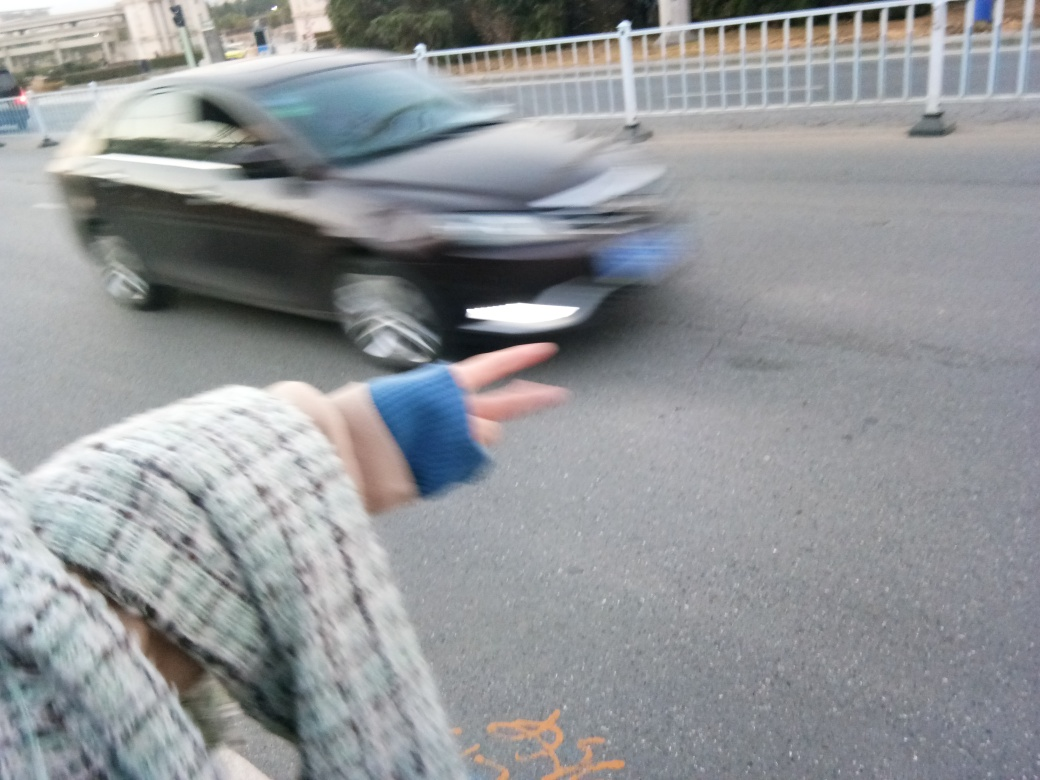Are there any clear and sharp subjects? While the foreground features an outstretched hand that is somewhat in focus, the rest of the image, especially the moving car, is blurred. This suggests a slower shutter speed or motion blur effect from the camera. The hand could be considered a clear subject, but because it occupies a relatively small portion of the frame and is not the central focus, the overall image lacks a predominant sharp subject. 